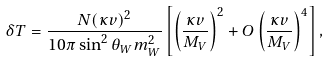<formula> <loc_0><loc_0><loc_500><loc_500>\delta T = \frac { N ( \kappa v ) ^ { 2 } } { 1 0 \pi \sin ^ { 2 } \theta _ { W } m ^ { 2 } _ { W } } \left [ \left ( \frac { \kappa v } { M _ { V } } \right ) ^ { 2 } + O \left ( \frac { \kappa v } { M _ { V } } \right ) ^ { 4 } \right ] ,</formula> 